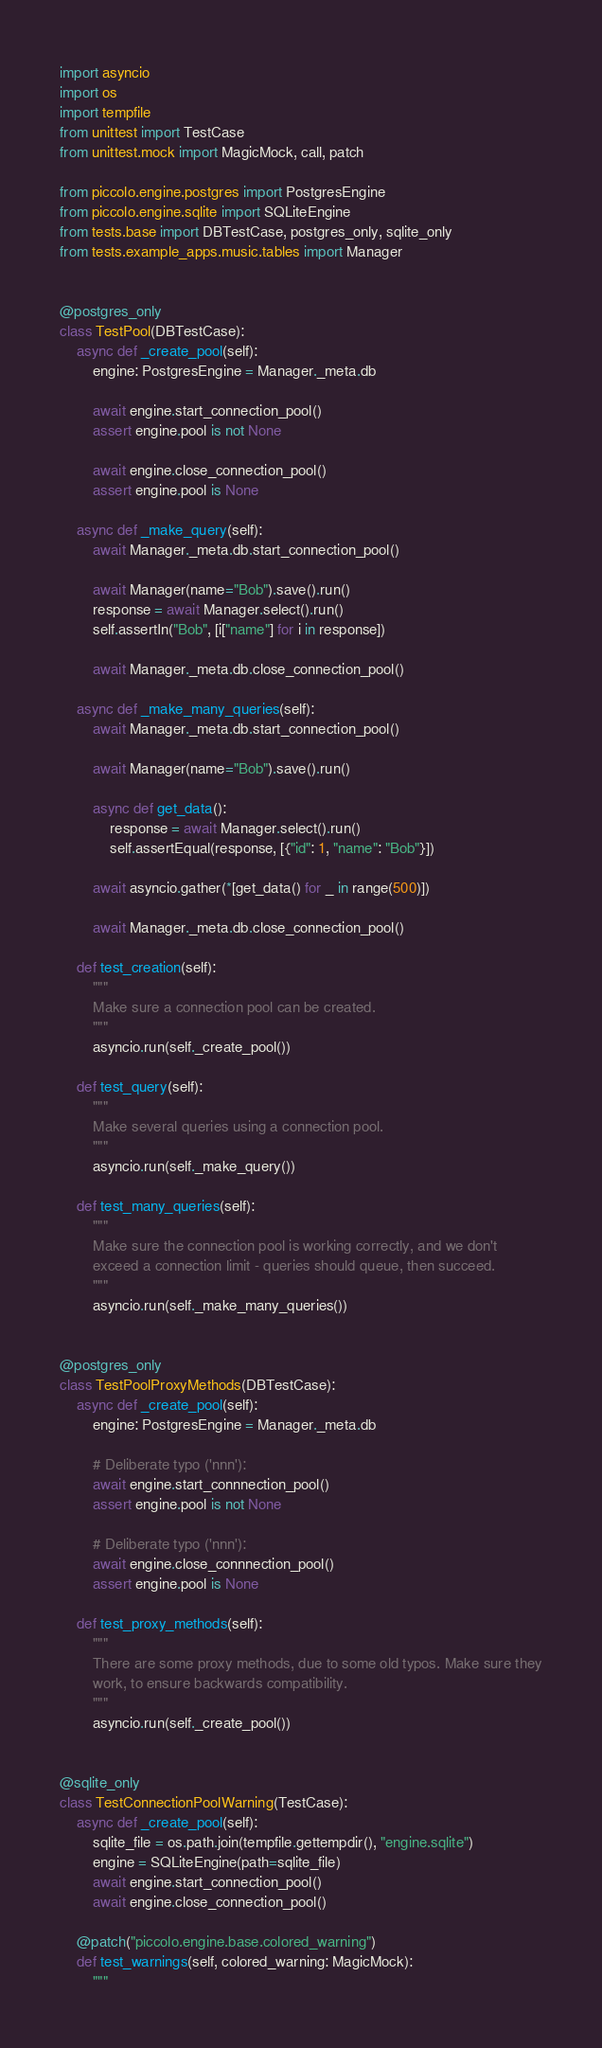Convert code to text. <code><loc_0><loc_0><loc_500><loc_500><_Python_>import asyncio
import os
import tempfile
from unittest import TestCase
from unittest.mock import MagicMock, call, patch

from piccolo.engine.postgres import PostgresEngine
from piccolo.engine.sqlite import SQLiteEngine
from tests.base import DBTestCase, postgres_only, sqlite_only
from tests.example_apps.music.tables import Manager


@postgres_only
class TestPool(DBTestCase):
    async def _create_pool(self):
        engine: PostgresEngine = Manager._meta.db

        await engine.start_connection_pool()
        assert engine.pool is not None

        await engine.close_connection_pool()
        assert engine.pool is None

    async def _make_query(self):
        await Manager._meta.db.start_connection_pool()

        await Manager(name="Bob").save().run()
        response = await Manager.select().run()
        self.assertIn("Bob", [i["name"] for i in response])

        await Manager._meta.db.close_connection_pool()

    async def _make_many_queries(self):
        await Manager._meta.db.start_connection_pool()

        await Manager(name="Bob").save().run()

        async def get_data():
            response = await Manager.select().run()
            self.assertEqual(response, [{"id": 1, "name": "Bob"}])

        await asyncio.gather(*[get_data() for _ in range(500)])

        await Manager._meta.db.close_connection_pool()

    def test_creation(self):
        """
        Make sure a connection pool can be created.
        """
        asyncio.run(self._create_pool())

    def test_query(self):
        """
        Make several queries using a connection pool.
        """
        asyncio.run(self._make_query())

    def test_many_queries(self):
        """
        Make sure the connection pool is working correctly, and we don't
        exceed a connection limit - queries should queue, then succeed.
        """
        asyncio.run(self._make_many_queries())


@postgres_only
class TestPoolProxyMethods(DBTestCase):
    async def _create_pool(self):
        engine: PostgresEngine = Manager._meta.db

        # Deliberate typo ('nnn'):
        await engine.start_connnection_pool()
        assert engine.pool is not None

        # Deliberate typo ('nnn'):
        await engine.close_connnection_pool()
        assert engine.pool is None

    def test_proxy_methods(self):
        """
        There are some proxy methods, due to some old typos. Make sure they
        work, to ensure backwards compatibility.
        """
        asyncio.run(self._create_pool())


@sqlite_only
class TestConnectionPoolWarning(TestCase):
    async def _create_pool(self):
        sqlite_file = os.path.join(tempfile.gettempdir(), "engine.sqlite")
        engine = SQLiteEngine(path=sqlite_file)
        await engine.start_connection_pool()
        await engine.close_connection_pool()

    @patch("piccolo.engine.base.colored_warning")
    def test_warnings(self, colored_warning: MagicMock):
        """</code> 